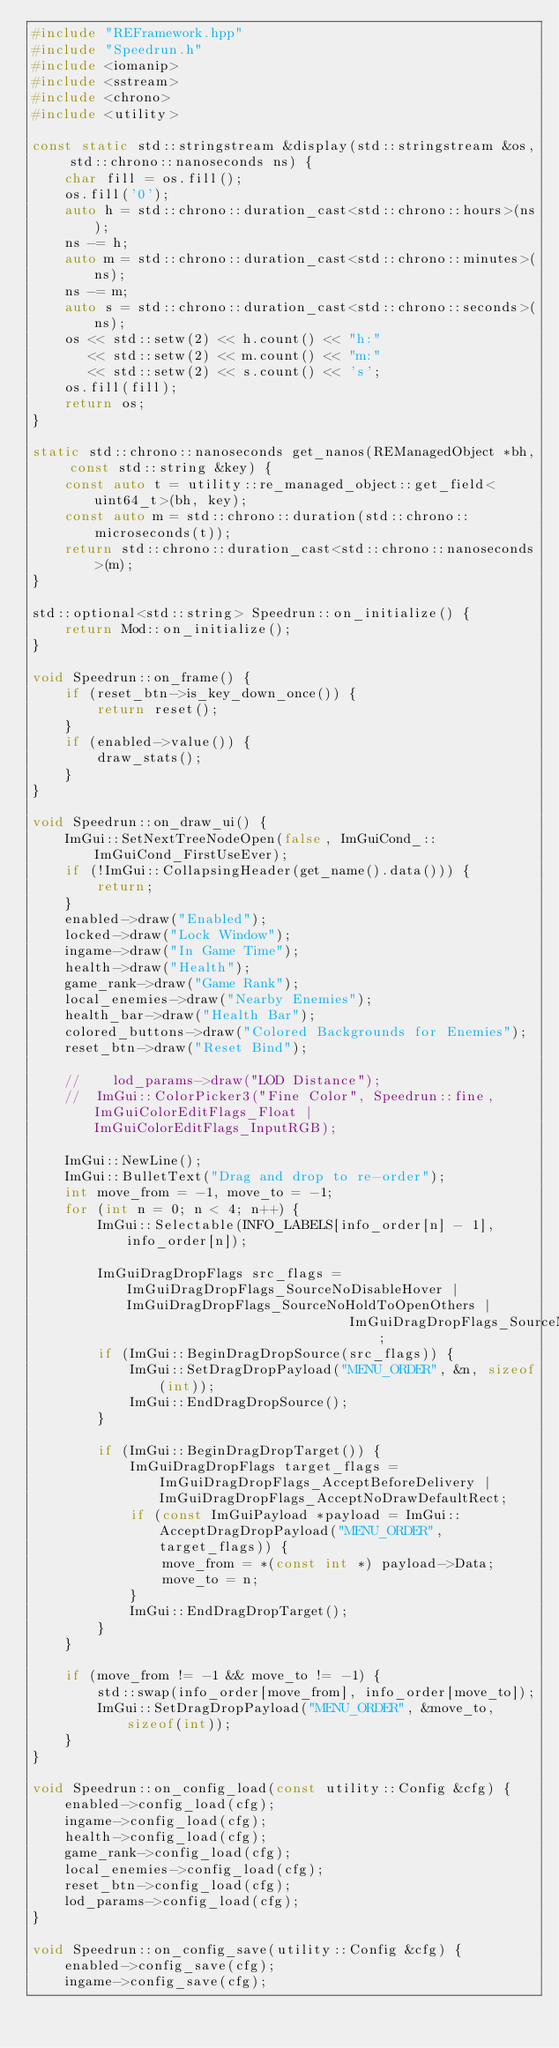<code> <loc_0><loc_0><loc_500><loc_500><_C++_>#include "REFramework.hpp"
#include "Speedrun.h"
#include <iomanip>
#include <sstream>
#include <chrono>
#include <utility>

const static std::stringstream &display(std::stringstream &os, std::chrono::nanoseconds ns) {
    char fill = os.fill();
    os.fill('0');
    auto h = std::chrono::duration_cast<std::chrono::hours>(ns);
    ns -= h;
    auto m = std::chrono::duration_cast<std::chrono::minutes>(ns);
    ns -= m;
    auto s = std::chrono::duration_cast<std::chrono::seconds>(ns);
    os << std::setw(2) << h.count() << "h:"
       << std::setw(2) << m.count() << "m:"
       << std::setw(2) << s.count() << 's';
    os.fill(fill);
    return os;
}

static std::chrono::nanoseconds get_nanos(REManagedObject *bh, const std::string &key) {
    const auto t = utility::re_managed_object::get_field<uint64_t>(bh, key);
    const auto m = std::chrono::duration(std::chrono::microseconds(t));
    return std::chrono::duration_cast<std::chrono::nanoseconds>(m);
}

std::optional<std::string> Speedrun::on_initialize() {
    return Mod::on_initialize();
}

void Speedrun::on_frame() {
    if (reset_btn->is_key_down_once()) {
        return reset();
    }
    if (enabled->value()) {
        draw_stats();
    }
}

void Speedrun::on_draw_ui() {
    ImGui::SetNextTreeNodeOpen(false, ImGuiCond_::ImGuiCond_FirstUseEver);
    if (!ImGui::CollapsingHeader(get_name().data())) {
        return;
    }
    enabled->draw("Enabled");
    locked->draw("Lock Window");
    ingame->draw("In Game Time");
    health->draw("Health");
    game_rank->draw("Game Rank");
    local_enemies->draw("Nearby Enemies");
    health_bar->draw("Health Bar");
    colored_buttons->draw("Colored Backgrounds for Enemies");
    reset_btn->draw("Reset Bind");

    //    lod_params->draw("LOD Distance");
    //  ImGui::ColorPicker3("Fine Color", Speedrun::fine, ImGuiColorEditFlags_Float | ImGuiColorEditFlags_InputRGB);

    ImGui::NewLine();
    ImGui::BulletText("Drag and drop to re-order");
    int move_from = -1, move_to = -1;
    for (int n = 0; n < 4; n++) {
        ImGui::Selectable(INFO_LABELS[info_order[n] - 1], info_order[n]);

        ImGuiDragDropFlags src_flags = ImGuiDragDropFlags_SourceNoDisableHover | ImGuiDragDropFlags_SourceNoHoldToOpenOthers |
                                       ImGuiDragDropFlags_SourceNoPreviewTooltip;
        if (ImGui::BeginDragDropSource(src_flags)) {
            ImGui::SetDragDropPayload("MENU_ORDER", &n, sizeof(int));
            ImGui::EndDragDropSource();
        }

        if (ImGui::BeginDragDropTarget()) {
            ImGuiDragDropFlags target_flags = ImGuiDragDropFlags_AcceptBeforeDelivery | ImGuiDragDropFlags_AcceptNoDrawDefaultRect;
            if (const ImGuiPayload *payload = ImGui::AcceptDragDropPayload("MENU_ORDER", target_flags)) {
                move_from = *(const int *) payload->Data;
                move_to = n;
            }
            ImGui::EndDragDropTarget();
        }
    }

    if (move_from != -1 && move_to != -1) {
        std::swap(info_order[move_from], info_order[move_to]);
        ImGui::SetDragDropPayload("MENU_ORDER", &move_to, sizeof(int));
    }
}

void Speedrun::on_config_load(const utility::Config &cfg) {
    enabled->config_load(cfg);
    ingame->config_load(cfg);
    health->config_load(cfg);
    game_rank->config_load(cfg);
    local_enemies->config_load(cfg);
    reset_btn->config_load(cfg);
    lod_params->config_load(cfg);
}

void Speedrun::on_config_save(utility::Config &cfg) {
    enabled->config_save(cfg);
    ingame->config_save(cfg);</code> 